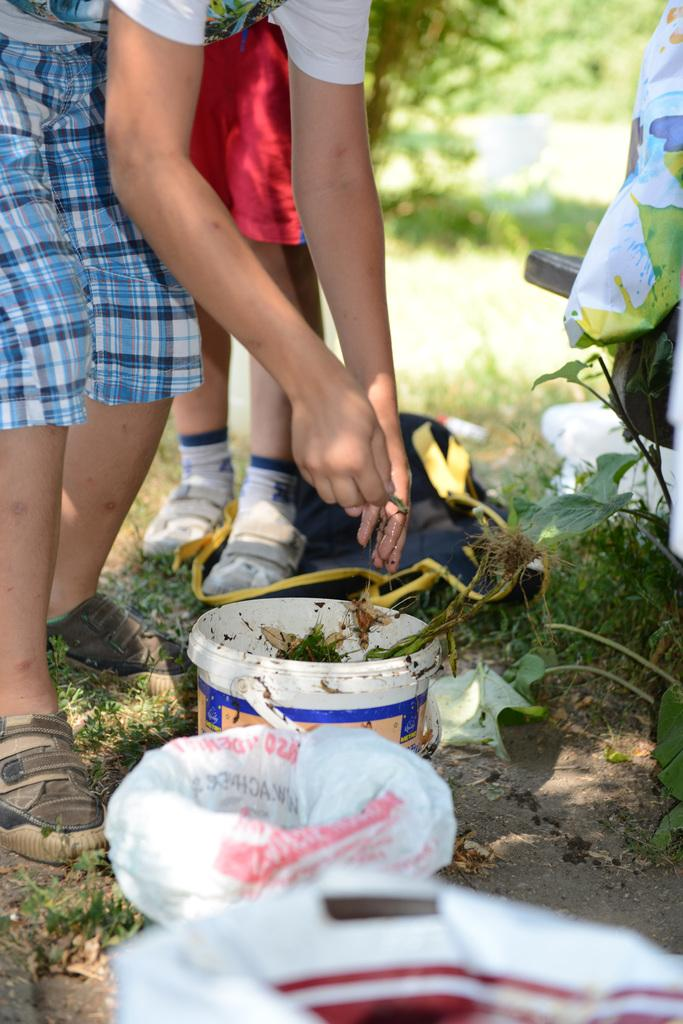What is the person holding in the image? There is a person holding something in the image, but the facts do not specify what it is. What objects are present in the image besides the person? There are buckets and plastic covers in the image. What type of vegetation can be seen in the image? There are plants and grass in the image. What type of punishment is being administered to the girl in the image? There is no girl present in the image, and therefore no punishment can be observed. 